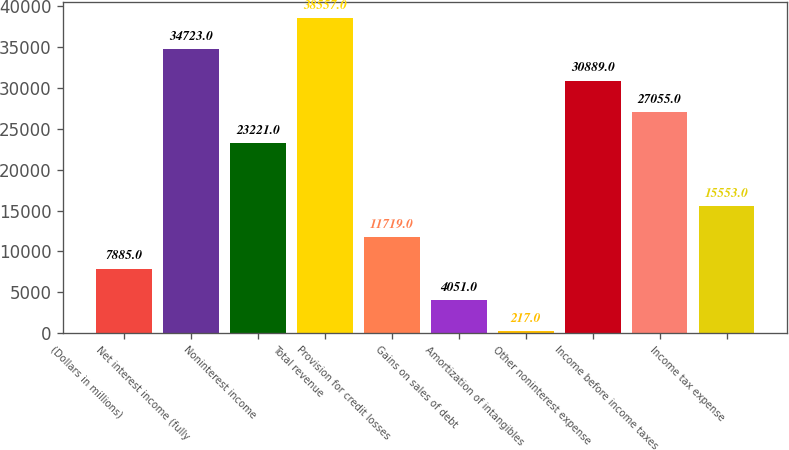Convert chart to OTSL. <chart><loc_0><loc_0><loc_500><loc_500><bar_chart><fcel>(Dollars in millions)<fcel>Net interest income (fully<fcel>Noninterest income<fcel>Total revenue<fcel>Provision for credit losses<fcel>Gains on sales of debt<fcel>Amortization of intangibles<fcel>Other noninterest expense<fcel>Income before income taxes<fcel>Income tax expense<nl><fcel>7885<fcel>34723<fcel>23221<fcel>38557<fcel>11719<fcel>4051<fcel>217<fcel>30889<fcel>27055<fcel>15553<nl></chart> 